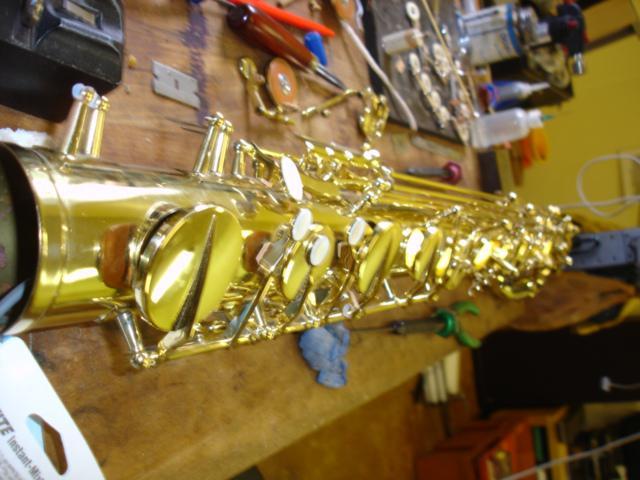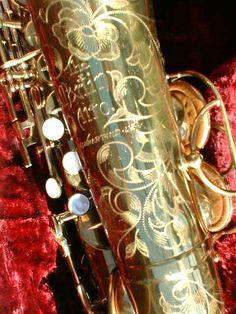The first image is the image on the left, the second image is the image on the right. For the images displayed, is the sentence "At least one saxophone has engraving on the surface of its body." factually correct? Answer yes or no. Yes. The first image is the image on the left, the second image is the image on the right. For the images shown, is this caption "One image shows a single rightward facing bell of a saxophone, and the other image shows a gold-colored leftward-facing saxophone in the foreground." true? Answer yes or no. No. 